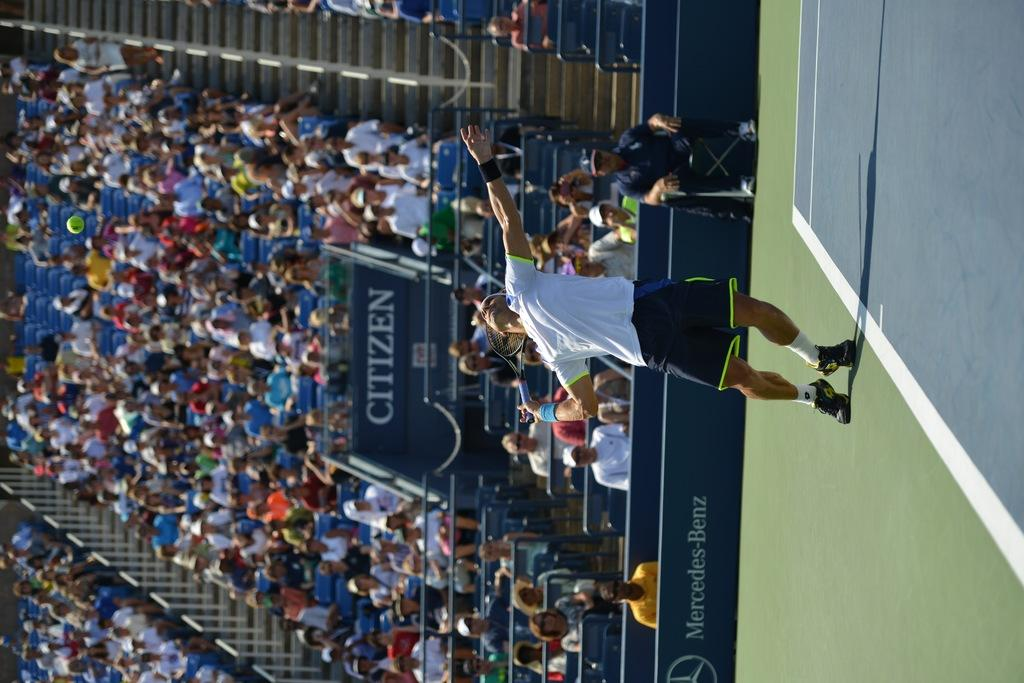What are the people in the image doing? The people in the image are sitting. How are the people arranged in the image? The people are sitting in order. What can be seen in the image besides the people? There is a player visible in the image. What type of location is depicted in the image? The setting is a stadium. What color is the ground in the stadium? The ground in the stadium is green. What type of cream is being used to bake the hand in the oven in the image? There is: There is no cream, hand, or oven present in the image. 